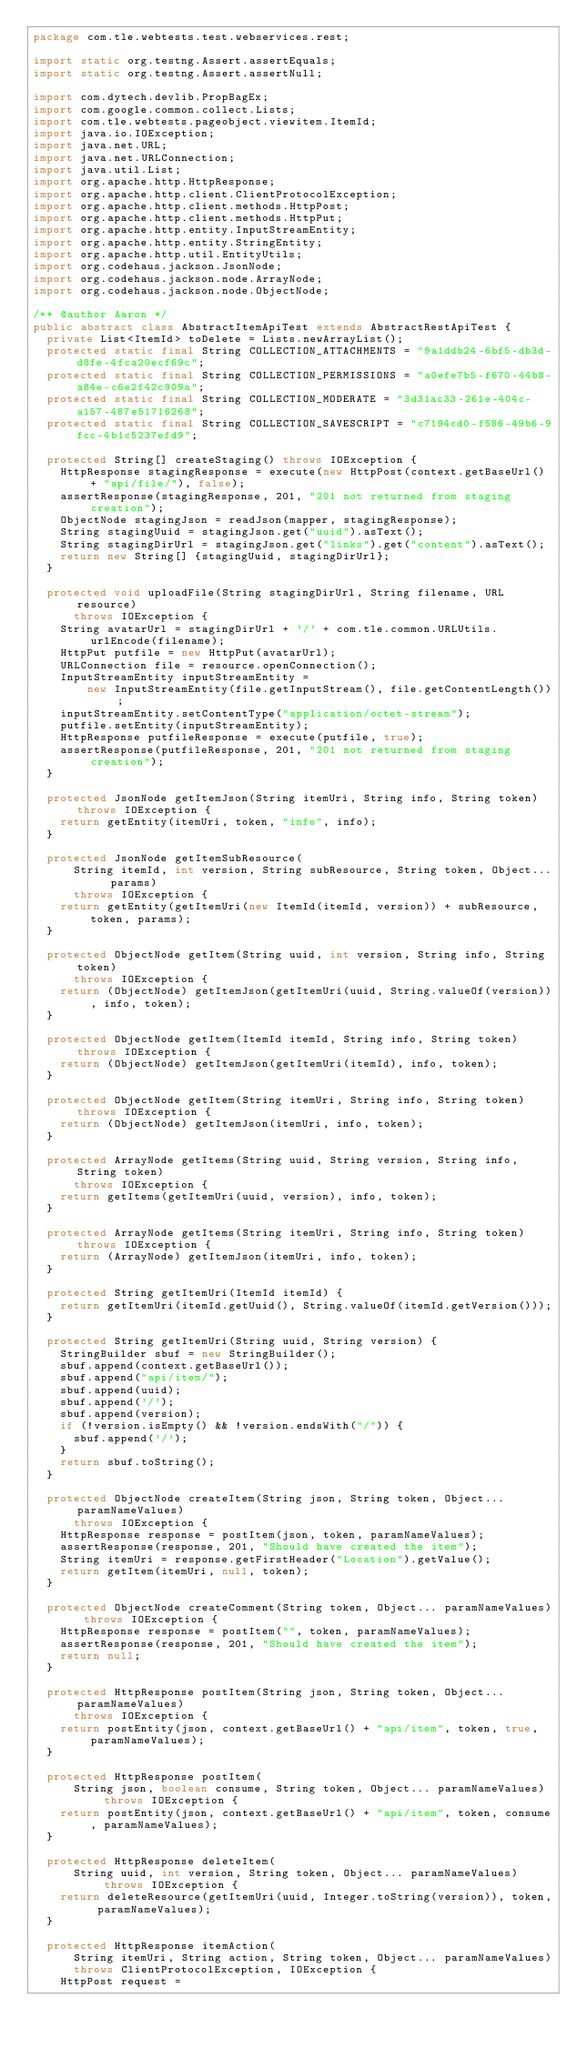<code> <loc_0><loc_0><loc_500><loc_500><_Java_>package com.tle.webtests.test.webservices.rest;

import static org.testng.Assert.assertEquals;
import static org.testng.Assert.assertNull;

import com.dytech.devlib.PropBagEx;
import com.google.common.collect.Lists;
import com.tle.webtests.pageobject.viewitem.ItemId;
import java.io.IOException;
import java.net.URL;
import java.net.URLConnection;
import java.util.List;
import org.apache.http.HttpResponse;
import org.apache.http.client.ClientProtocolException;
import org.apache.http.client.methods.HttpPost;
import org.apache.http.client.methods.HttpPut;
import org.apache.http.entity.InputStreamEntity;
import org.apache.http.entity.StringEntity;
import org.apache.http.util.EntityUtils;
import org.codehaus.jackson.JsonNode;
import org.codehaus.jackson.node.ArrayNode;
import org.codehaus.jackson.node.ObjectNode;

/** @author Aaron */
public abstract class AbstractItemApiTest extends AbstractRestApiTest {
  private List<ItemId> toDelete = Lists.newArrayList();
  protected static final String COLLECTION_ATTACHMENTS = "9a1ddb24-6bf5-db3d-d8fe-4fca20ecf69c";
  protected static final String COLLECTION_PERMISSIONS = "a0efe7b5-f670-44b8-a84e-c6e2f42c909a";
  protected static final String COLLECTION_MODERATE = "3d31ac33-261e-404c-a157-487e51716268";
  protected static final String COLLECTION_SAVESCRIPT = "c7194cd0-f586-49b6-9fcc-4b1c5237efd9";

  protected String[] createStaging() throws IOException {
    HttpResponse stagingResponse = execute(new HttpPost(context.getBaseUrl() + "api/file/"), false);
    assertResponse(stagingResponse, 201, "201 not returned from staging creation");
    ObjectNode stagingJson = readJson(mapper, stagingResponse);
    String stagingUuid = stagingJson.get("uuid").asText();
    String stagingDirUrl = stagingJson.get("links").get("content").asText();
    return new String[] {stagingUuid, stagingDirUrl};
  }

  protected void uploadFile(String stagingDirUrl, String filename, URL resource)
      throws IOException {
    String avatarUrl = stagingDirUrl + '/' + com.tle.common.URLUtils.urlEncode(filename);
    HttpPut putfile = new HttpPut(avatarUrl);
    URLConnection file = resource.openConnection();
    InputStreamEntity inputStreamEntity =
        new InputStreamEntity(file.getInputStream(), file.getContentLength());
    inputStreamEntity.setContentType("application/octet-stream");
    putfile.setEntity(inputStreamEntity);
    HttpResponse putfileResponse = execute(putfile, true);
    assertResponse(putfileResponse, 201, "201 not returned from staging creation");
  }

  protected JsonNode getItemJson(String itemUri, String info, String token) throws IOException {
    return getEntity(itemUri, token, "info", info);
  }

  protected JsonNode getItemSubResource(
      String itemId, int version, String subResource, String token, Object... params)
      throws IOException {
    return getEntity(getItemUri(new ItemId(itemId, version)) + subResource, token, params);
  }

  protected ObjectNode getItem(String uuid, int version, String info, String token)
      throws IOException {
    return (ObjectNode) getItemJson(getItemUri(uuid, String.valueOf(version)), info, token);
  }

  protected ObjectNode getItem(ItemId itemId, String info, String token) throws IOException {
    return (ObjectNode) getItemJson(getItemUri(itemId), info, token);
  }

  protected ObjectNode getItem(String itemUri, String info, String token) throws IOException {
    return (ObjectNode) getItemJson(itemUri, info, token);
  }

  protected ArrayNode getItems(String uuid, String version, String info, String token)
      throws IOException {
    return getItems(getItemUri(uuid, version), info, token);
  }

  protected ArrayNode getItems(String itemUri, String info, String token) throws IOException {
    return (ArrayNode) getItemJson(itemUri, info, token);
  }

  protected String getItemUri(ItemId itemId) {
    return getItemUri(itemId.getUuid(), String.valueOf(itemId.getVersion()));
  }

  protected String getItemUri(String uuid, String version) {
    StringBuilder sbuf = new StringBuilder();
    sbuf.append(context.getBaseUrl());
    sbuf.append("api/item/");
    sbuf.append(uuid);
    sbuf.append('/');
    sbuf.append(version);
    if (!version.isEmpty() && !version.endsWith("/")) {
      sbuf.append('/');
    }
    return sbuf.toString();
  }

  protected ObjectNode createItem(String json, String token, Object... paramNameValues)
      throws IOException {
    HttpResponse response = postItem(json, token, paramNameValues);
    assertResponse(response, 201, "Should have created the item");
    String itemUri = response.getFirstHeader("Location").getValue();
    return getItem(itemUri, null, token);
  }

  protected ObjectNode createComment(String token, Object... paramNameValues) throws IOException {
    HttpResponse response = postItem("", token, paramNameValues);
    assertResponse(response, 201, "Should have created the item");
    return null;
  }

  protected HttpResponse postItem(String json, String token, Object... paramNameValues)
      throws IOException {
    return postEntity(json, context.getBaseUrl() + "api/item", token, true, paramNameValues);
  }

  protected HttpResponse postItem(
      String json, boolean consume, String token, Object... paramNameValues) throws IOException {
    return postEntity(json, context.getBaseUrl() + "api/item", token, consume, paramNameValues);
  }

  protected HttpResponse deleteItem(
      String uuid, int version, String token, Object... paramNameValues) throws IOException {
    return deleteResource(getItemUri(uuid, Integer.toString(version)), token, paramNameValues);
  }

  protected HttpResponse itemAction(
      String itemUri, String action, String token, Object... paramNameValues)
      throws ClientProtocolException, IOException {
    HttpPost request =</code> 